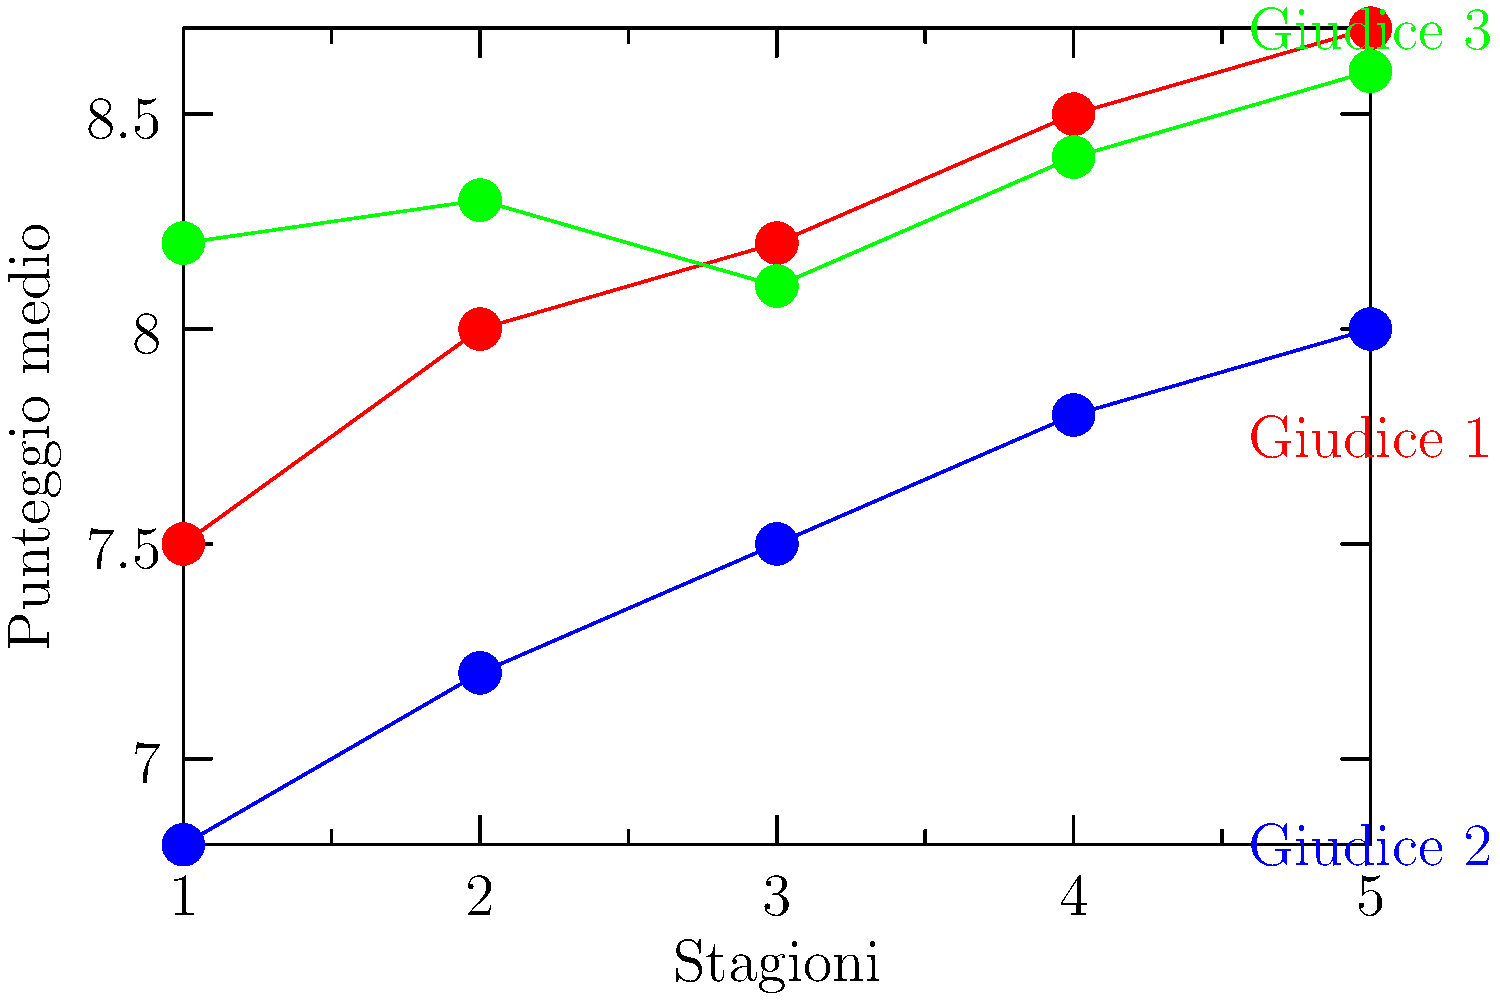Analizzando il grafico che mostra i punteggi medi dei giudici di Ballando con le Stelle nelle ultime cinque stagioni, quale giudice ha mostrato la crescita più costante nei suoi punteggi? Per determinare quale giudice ha mostrato la crescita più costante nei punteggi, dobbiamo analizzare le linee del grafico per ciascun giudice:

1. Giudice 1 (linea rossa):
   - Inizia da 7.5 nella stagione 1
   - Aumenta costantemente ogni stagione
   - Finisce a 8.7 nella stagione 5
   - Mostra una crescita costante e graduale

2. Giudice 2 (linea blu):
   - Inizia da 6.8 nella stagione 1
   - Aumenta costantemente ogni stagione
   - Finisce a 8.0 nella stagione 5
   - Mostra una crescita costante e graduale, simile al Giudice 1

3. Giudice 3 (linea verde):
   - Inizia da 8.2 nella stagione 1
   - Fluttua leggermente nelle prime tre stagioni
   - Aumenta nelle ultime due stagioni
   - Finisce a 8.6 nella stagione 5
   - Mostra una crescita meno costante rispetto agli altri due giudici

Confrontando le tre linee, possiamo vedere che il Giudice 1 e il Giudice 2 mostrano entrambi una crescita costante e graduale. Tuttavia, il Giudice 1 ha una linea leggermente più uniforme e un aumento più marcato nel punteggio complessivo (da 7.5 a 8.7).
Answer: Giudice 1 